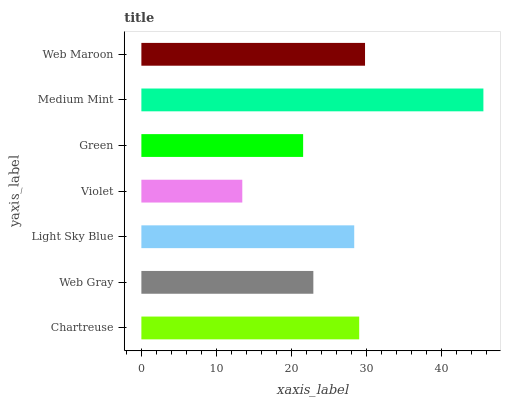Is Violet the minimum?
Answer yes or no. Yes. Is Medium Mint the maximum?
Answer yes or no. Yes. Is Web Gray the minimum?
Answer yes or no. No. Is Web Gray the maximum?
Answer yes or no. No. Is Chartreuse greater than Web Gray?
Answer yes or no. Yes. Is Web Gray less than Chartreuse?
Answer yes or no. Yes. Is Web Gray greater than Chartreuse?
Answer yes or no. No. Is Chartreuse less than Web Gray?
Answer yes or no. No. Is Light Sky Blue the high median?
Answer yes or no. Yes. Is Light Sky Blue the low median?
Answer yes or no. Yes. Is Web Maroon the high median?
Answer yes or no. No. Is Chartreuse the low median?
Answer yes or no. No. 